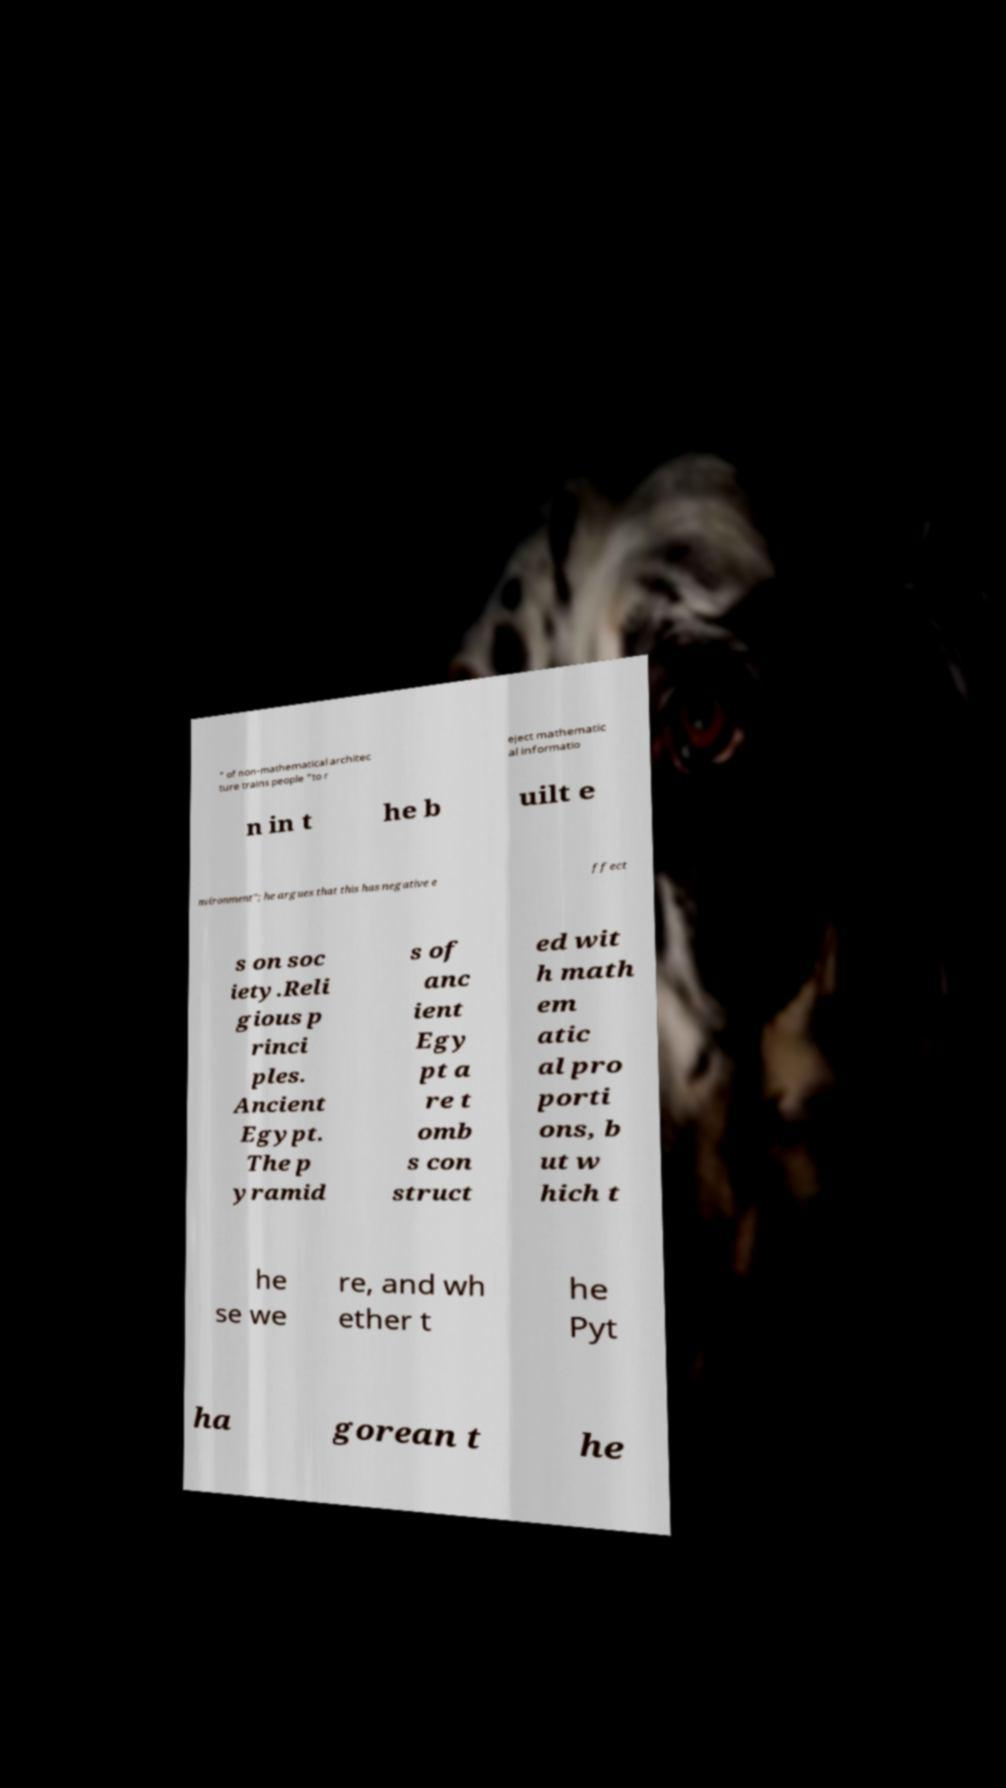Could you assist in decoding the text presented in this image and type it out clearly? " of non-mathematical architec ture trains people "to r eject mathematic al informatio n in t he b uilt e nvironment"; he argues that this has negative e ffect s on soc iety.Reli gious p rinci ples. Ancient Egypt. The p yramid s of anc ient Egy pt a re t omb s con struct ed wit h math em atic al pro porti ons, b ut w hich t he se we re, and wh ether t he Pyt ha gorean t he 